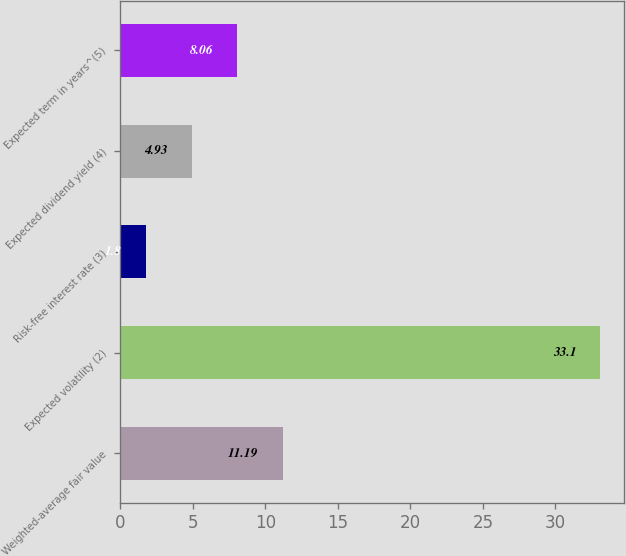Convert chart. <chart><loc_0><loc_0><loc_500><loc_500><bar_chart><fcel>Weighted-average fair value<fcel>Expected volatility (2)<fcel>Risk-free interest rate (3)<fcel>Expected dividend yield (4)<fcel>Expected term in years^(5)<nl><fcel>11.19<fcel>33.1<fcel>1.8<fcel>4.93<fcel>8.06<nl></chart> 